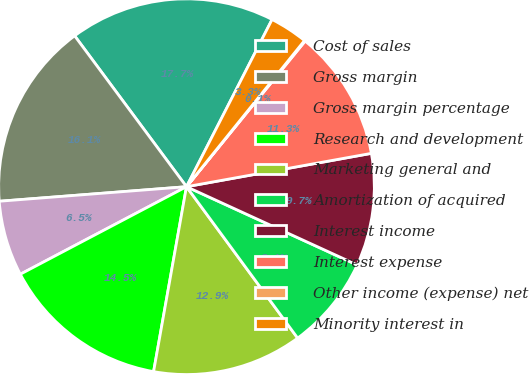Convert chart. <chart><loc_0><loc_0><loc_500><loc_500><pie_chart><fcel>Cost of sales<fcel>Gross margin<fcel>Gross margin percentage<fcel>Research and development<fcel>Marketing general and<fcel>Amortization of acquired<fcel>Interest income<fcel>Interest expense<fcel>Other income (expense) net<fcel>Minority interest in<nl><fcel>17.68%<fcel>16.08%<fcel>6.48%<fcel>14.48%<fcel>12.88%<fcel>8.08%<fcel>9.68%<fcel>11.28%<fcel>0.07%<fcel>3.28%<nl></chart> 